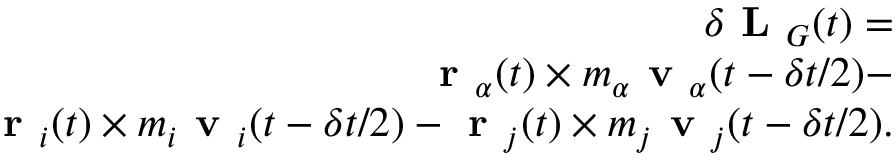<formula> <loc_0><loc_0><loc_500><loc_500>\begin{array} { r } { \delta L _ { G } ( t ) = } \\ { r _ { \alpha } ( t ) \times m _ { \alpha } v _ { \alpha } ( t - \delta t / 2 ) - } \\ { r _ { i } ( t ) \times m _ { i } v _ { i } ( t - \delta t / 2 ) - r _ { j } ( t ) \times m _ { j } v _ { j } ( t - \delta t / 2 ) . } \end{array}</formula> 